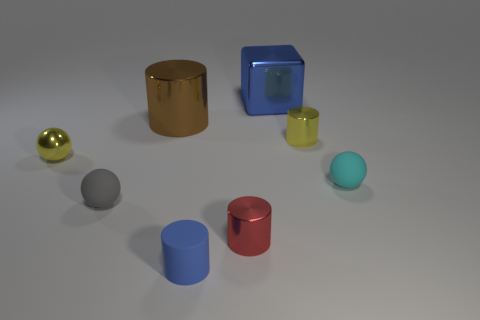Add 1 small cyan matte balls. How many objects exist? 9 Subtract all cubes. How many objects are left? 7 Add 7 blue metallic cubes. How many blue metallic cubes are left? 8 Add 4 large purple matte cylinders. How many large purple matte cylinders exist? 4 Subtract 0 blue spheres. How many objects are left? 8 Subtract all tiny things. Subtract all small red things. How many objects are left? 1 